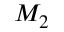Convert formula to latex. <formula><loc_0><loc_0><loc_500><loc_500>M _ { 2 }</formula> 